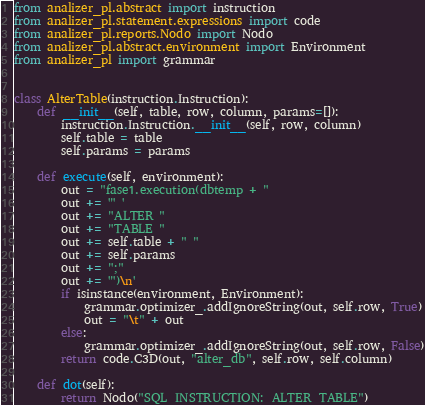Convert code to text. <code><loc_0><loc_0><loc_500><loc_500><_Python_>from analizer_pl.abstract import instruction
from analizer_pl.statement.expressions import code
from analizer_pl.reports.Nodo import Nodo
from analizer_pl.abstract.environment import Environment
from analizer_pl import grammar


class AlterTable(instruction.Instruction):
    def __init__(self, table, row, column, params=[]):
        instruction.Instruction.__init__(self, row, column)
        self.table = table
        self.params = params

    def execute(self, environment):
        out = "fase1.execution(dbtemp + "
        out += '" '
        out += "ALTER "
        out += "TABLE "
        out += self.table + " "
        out += self.params
        out += ";"
        out += '")\n'
        if isinstance(environment, Environment):
            grammar.optimizer_.addIgnoreString(out, self.row, True)
            out = "\t" + out
        else:
            grammar.optimizer_.addIgnoreString(out, self.row, False)
        return code.C3D(out, "alter_db", self.row, self.column)

    def dot(self):
        return Nodo("SQL_INSTRUCTION:_ALTER_TABLE")
</code> 